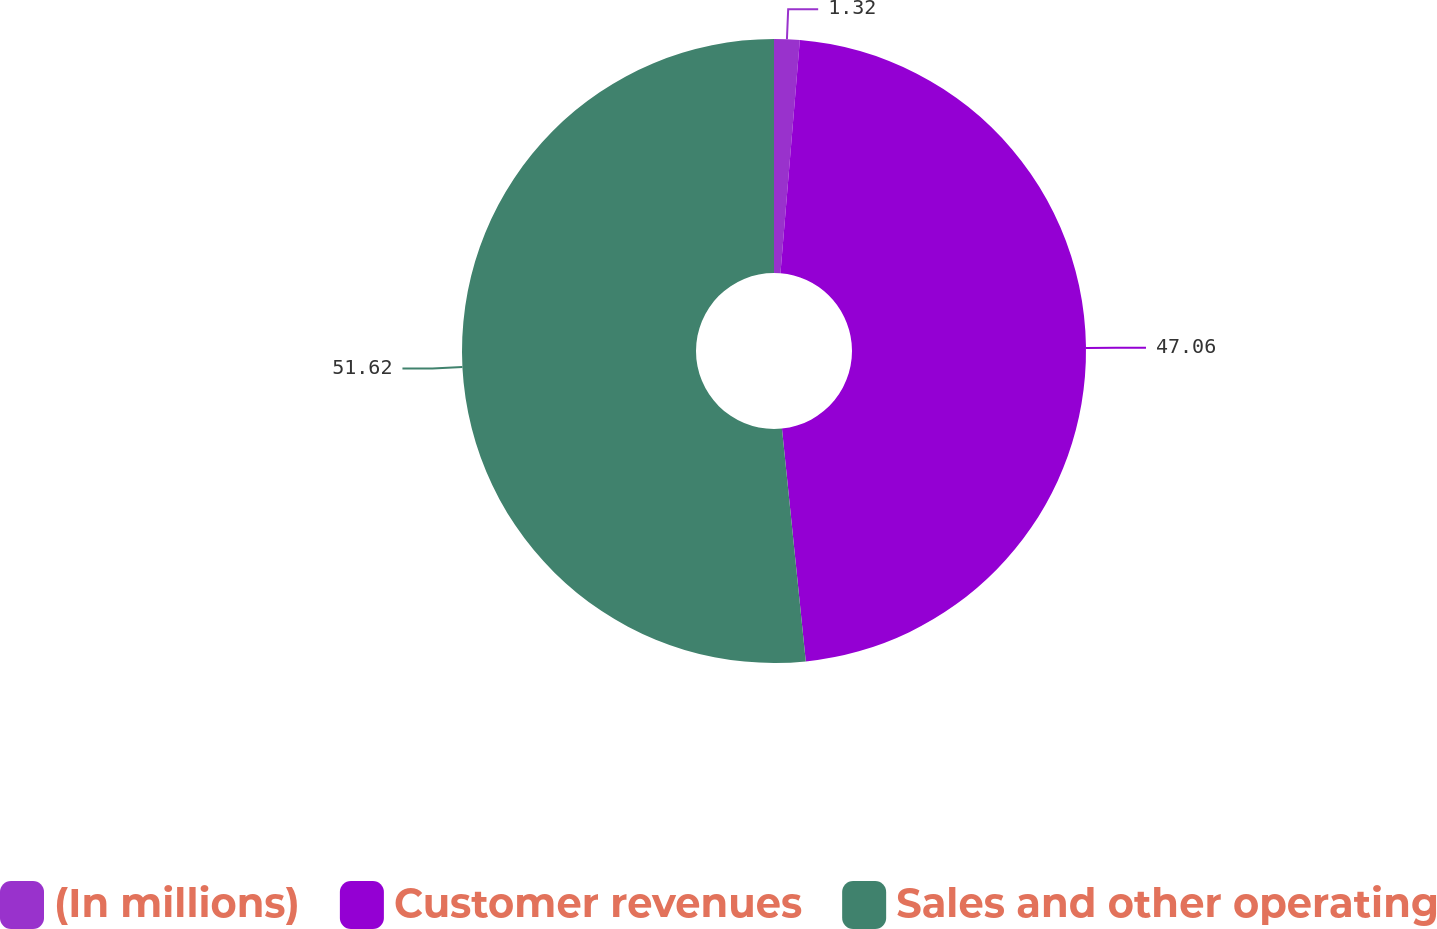Convert chart. <chart><loc_0><loc_0><loc_500><loc_500><pie_chart><fcel>(In millions)<fcel>Customer revenues<fcel>Sales and other operating<nl><fcel>1.32%<fcel>47.06%<fcel>51.63%<nl></chart> 